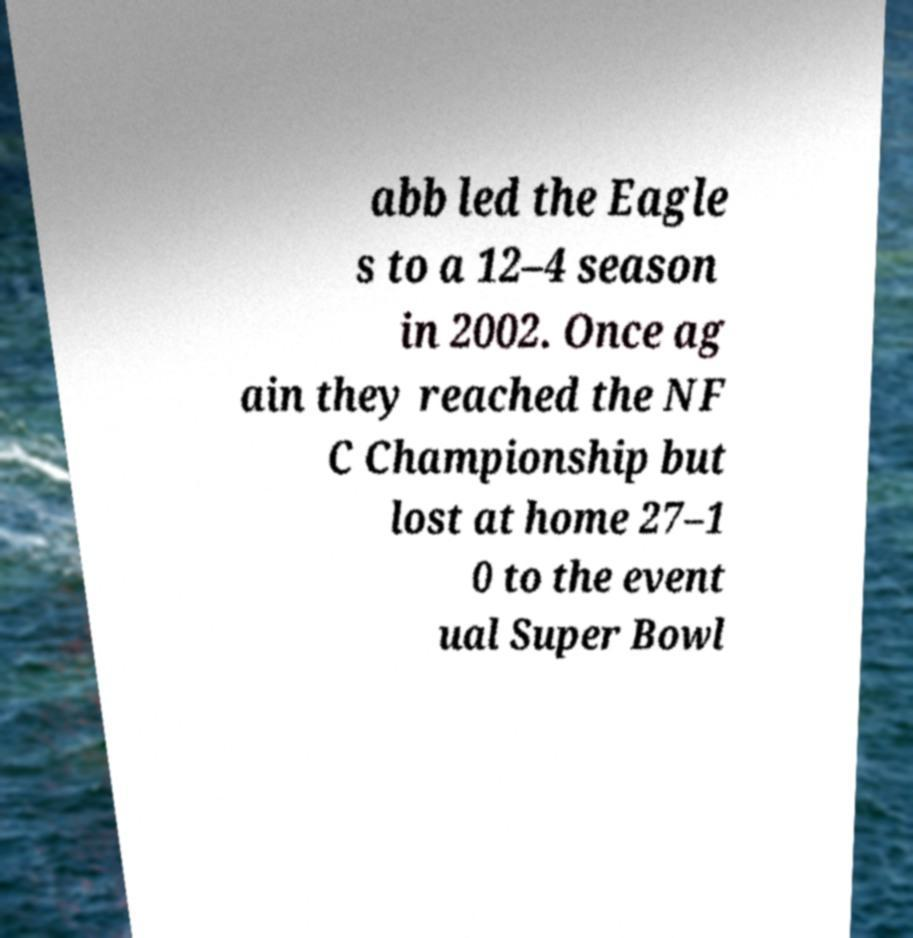Please identify and transcribe the text found in this image. abb led the Eagle s to a 12–4 season in 2002. Once ag ain they reached the NF C Championship but lost at home 27–1 0 to the event ual Super Bowl 